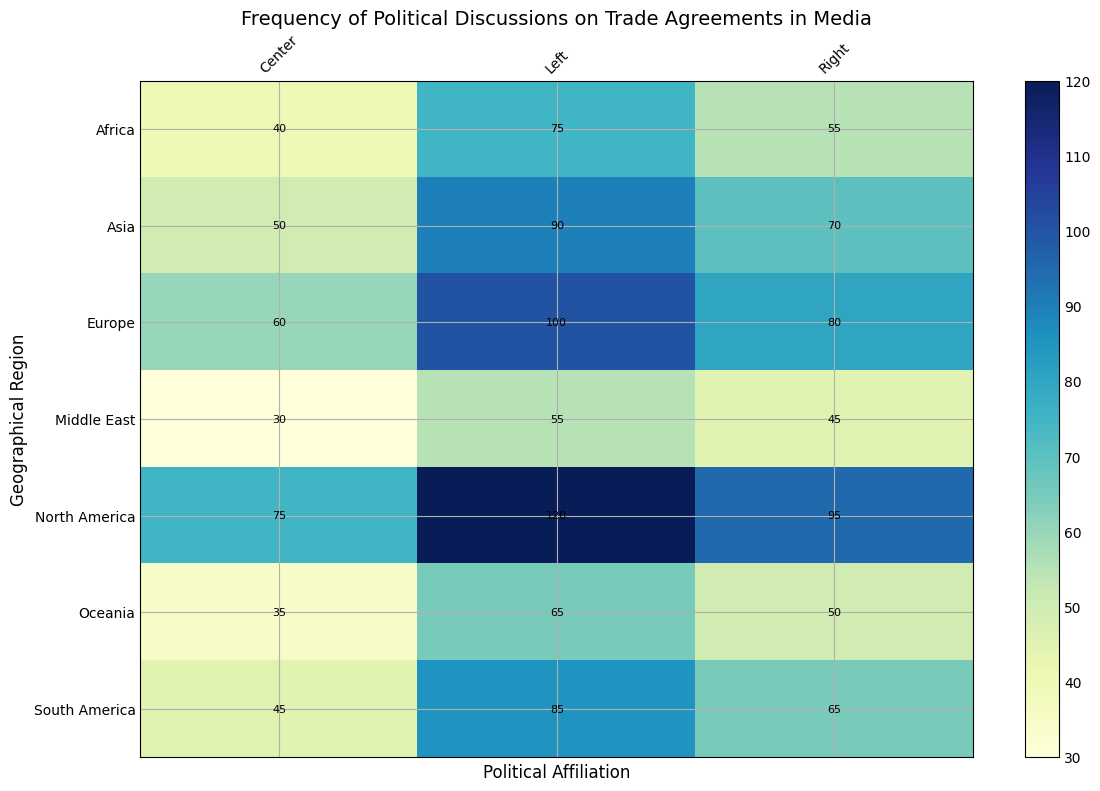Which geographical region has the highest frequency of political discussions about trade agreements for the Left political affiliation? By looking at the highest value in the Left column, North America has a frequency of 120, which is the highest.
Answer: North America Which political affiliation in Europe has the lowest frequency of political discussions about trade agreements? By comparing the values of each political affiliation in Europe: Left (100), Center (60), and Right (80), the Center has the lowest frequency.
Answer: Center In Asia, how much higher is the frequency of political discussions for the Left affiliation compared to the Center affiliation? Subtract the Center frequency from the Left frequency in Asia (90 - 50) to get the difference.
Answer: 40 What is the average frequency of political discussions about trade agreements in Africa across all political affiliations? Add the frequencies for Left, Center, and Right in Africa (75 + 40 + 55) and divide by 3: (75 + 40 + 55) / 3 = 56.67.
Answer: 56.67 How does the frequency of political discussions about trade agreements for the Right affiliation in South America compare to the Center affiliation in Oceania? By looking at the respective frequencies: South America Right (65) and Oceania Center (35). The South America Right frequency is higher than the Oceania Center frequency.
Answer: South America Right is higher In Oceania, which political affiliation has the highest frequency of political discussions about trade agreements? By comparing the values in Oceania for Left (65), Center (35), and Right (50), the Left has the highest frequency.
Answer: Left What is the difference between the highest and lowest frequencies of political discussions about trade agreements observed in any political affiliation across all regions? The highest frequency is North America Left (120) and the lowest frequency is Middle East Center (30). The difference is 120 - 30 = 90.
Answer: 90 